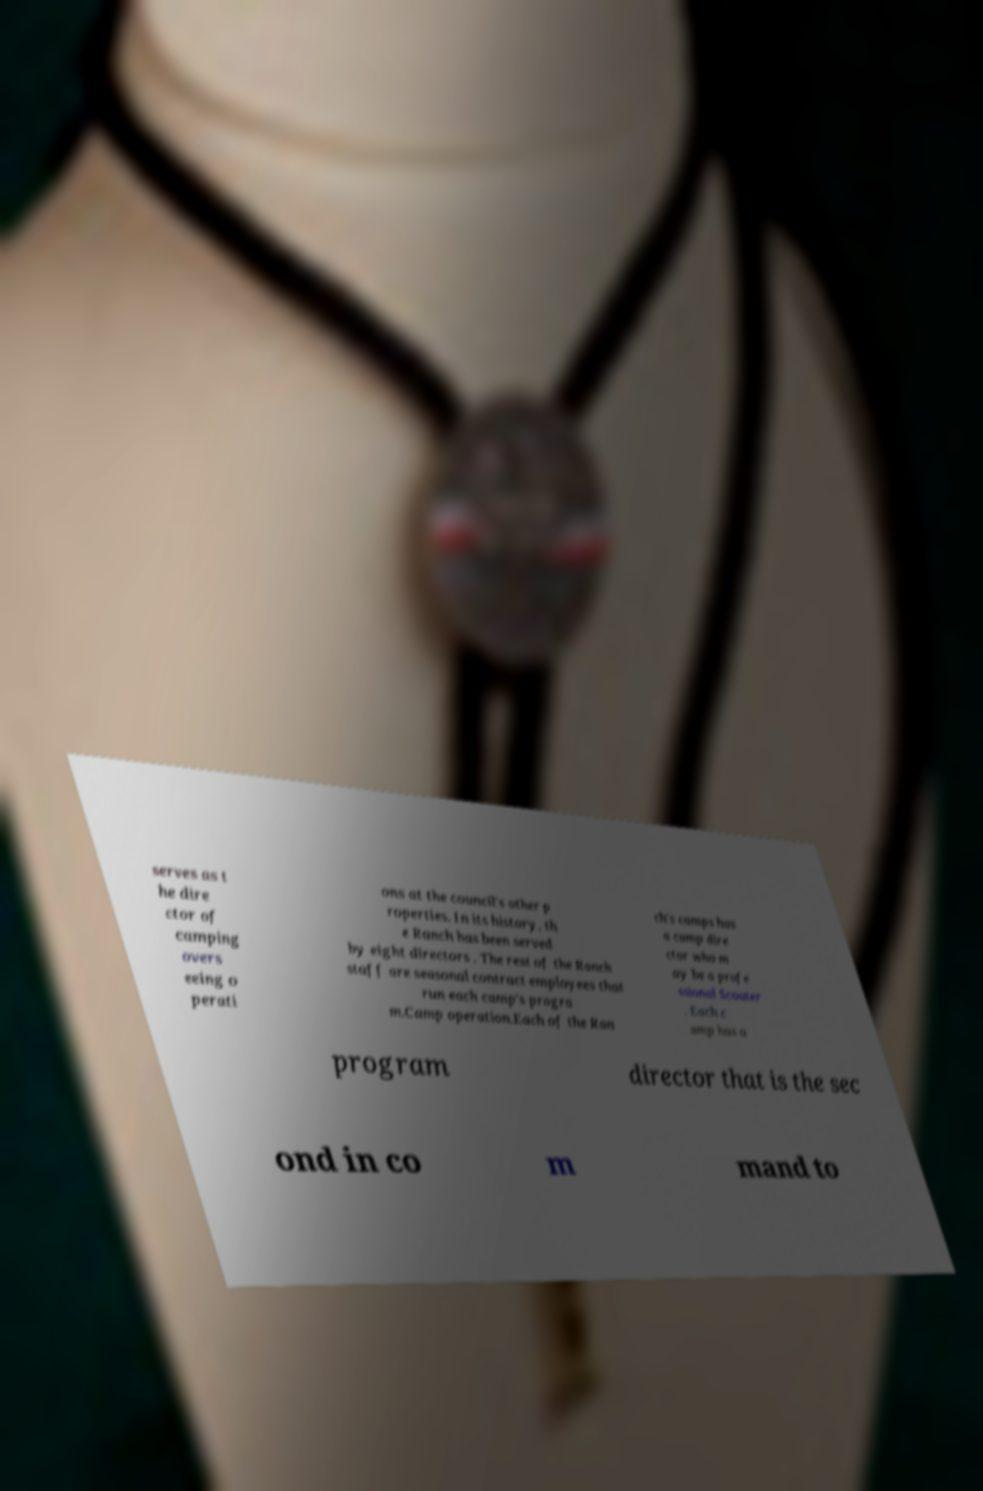Please identify and transcribe the text found in this image. serves as t he dire ctor of camping overs eeing o perati ons at the council's other p roperties. In its history, th e Ranch has been served by eight directors . The rest of the Ranch staff are seasonal contract employees that run each camp's progra m.Camp operation.Each of the Ran ch's camps has a camp dire ctor who m ay be a profe ssional Scouter . Each c amp has a program director that is the sec ond in co m mand to 